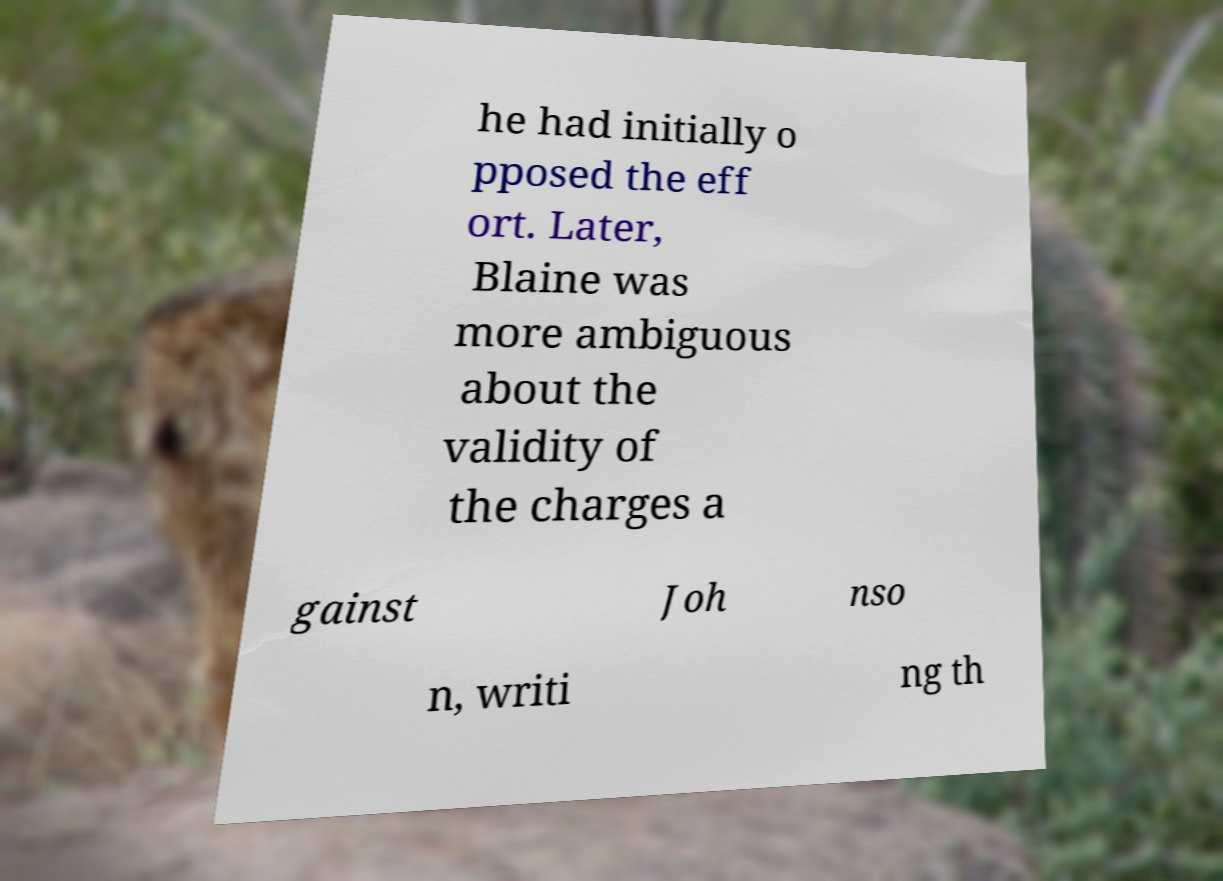For documentation purposes, I need the text within this image transcribed. Could you provide that? he had initially o pposed the eff ort. Later, Blaine was more ambiguous about the validity of the charges a gainst Joh nso n, writi ng th 